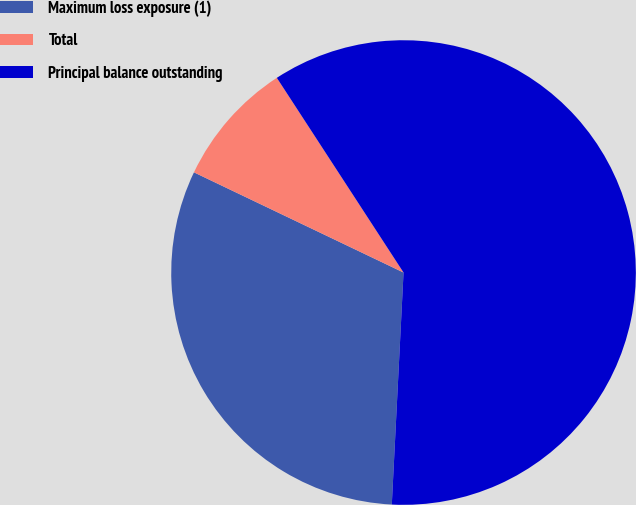Convert chart. <chart><loc_0><loc_0><loc_500><loc_500><pie_chart><fcel>Maximum loss exposure (1)<fcel>Total<fcel>Principal balance outstanding<nl><fcel>31.29%<fcel>8.72%<fcel>59.98%<nl></chart> 